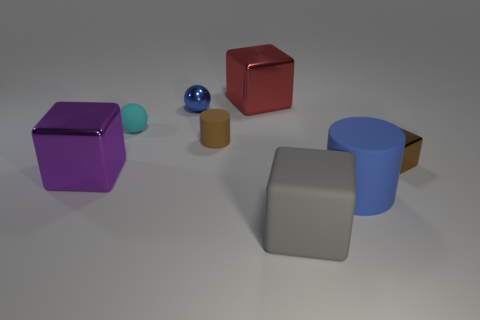Subtract all metal blocks. How many blocks are left? 1 Add 1 cubes. How many objects exist? 9 Subtract all cyan cubes. Subtract all purple balls. How many cubes are left? 4 Subtract all small cyan objects. Subtract all rubber things. How many objects are left? 3 Add 2 brown shiny things. How many brown shiny things are left? 3 Add 4 tiny brown metallic cubes. How many tiny brown metallic cubes exist? 5 Subtract 0 cyan cubes. How many objects are left? 8 Subtract all cylinders. How many objects are left? 6 